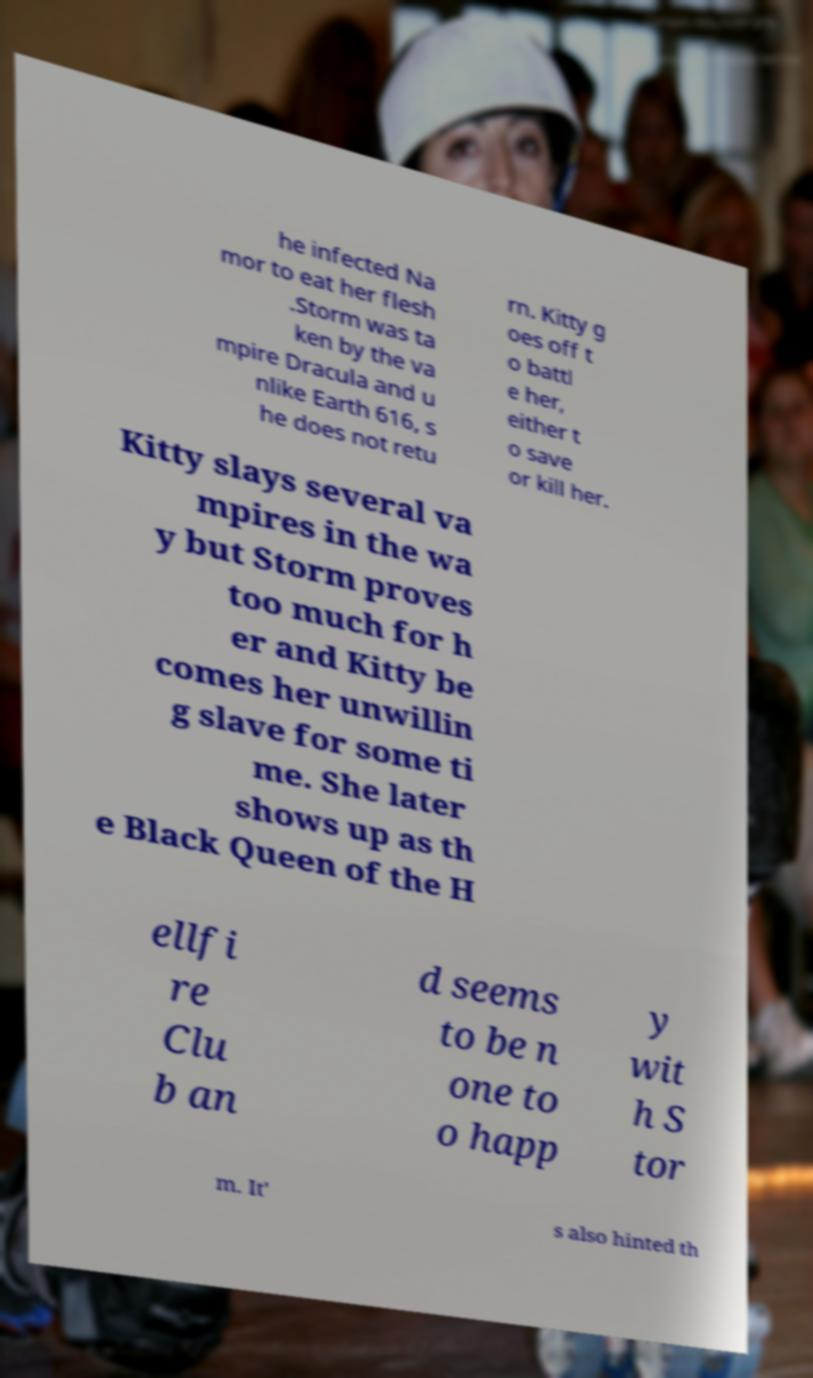Could you assist in decoding the text presented in this image and type it out clearly? he infected Na mor to eat her flesh .Storm was ta ken by the va mpire Dracula and u nlike Earth 616, s he does not retu rn. Kitty g oes off t o battl e her, either t o save or kill her. Kitty slays several va mpires in the wa y but Storm proves too much for h er and Kitty be comes her unwillin g slave for some ti me. She later shows up as th e Black Queen of the H ellfi re Clu b an d seems to be n one to o happ y wit h S tor m. It' s also hinted th 